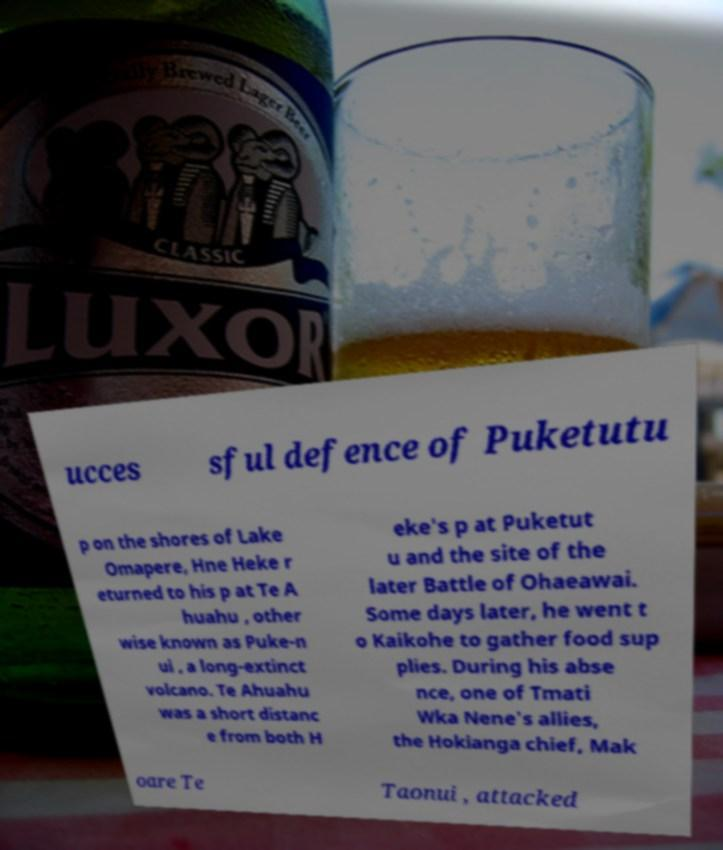Could you extract and type out the text from this image? ucces sful defence of Puketutu p on the shores of Lake Omapere, Hne Heke r eturned to his p at Te A huahu , other wise known as Puke-n ui , a long-extinct volcano. Te Ahuahu was a short distanc e from both H eke's p at Puketut u and the site of the later Battle of Ohaeawai. Some days later, he went t o Kaikohe to gather food sup plies. During his abse nce, one of Tmati Wka Nene's allies, the Hokianga chief, Mak oare Te Taonui , attacked 